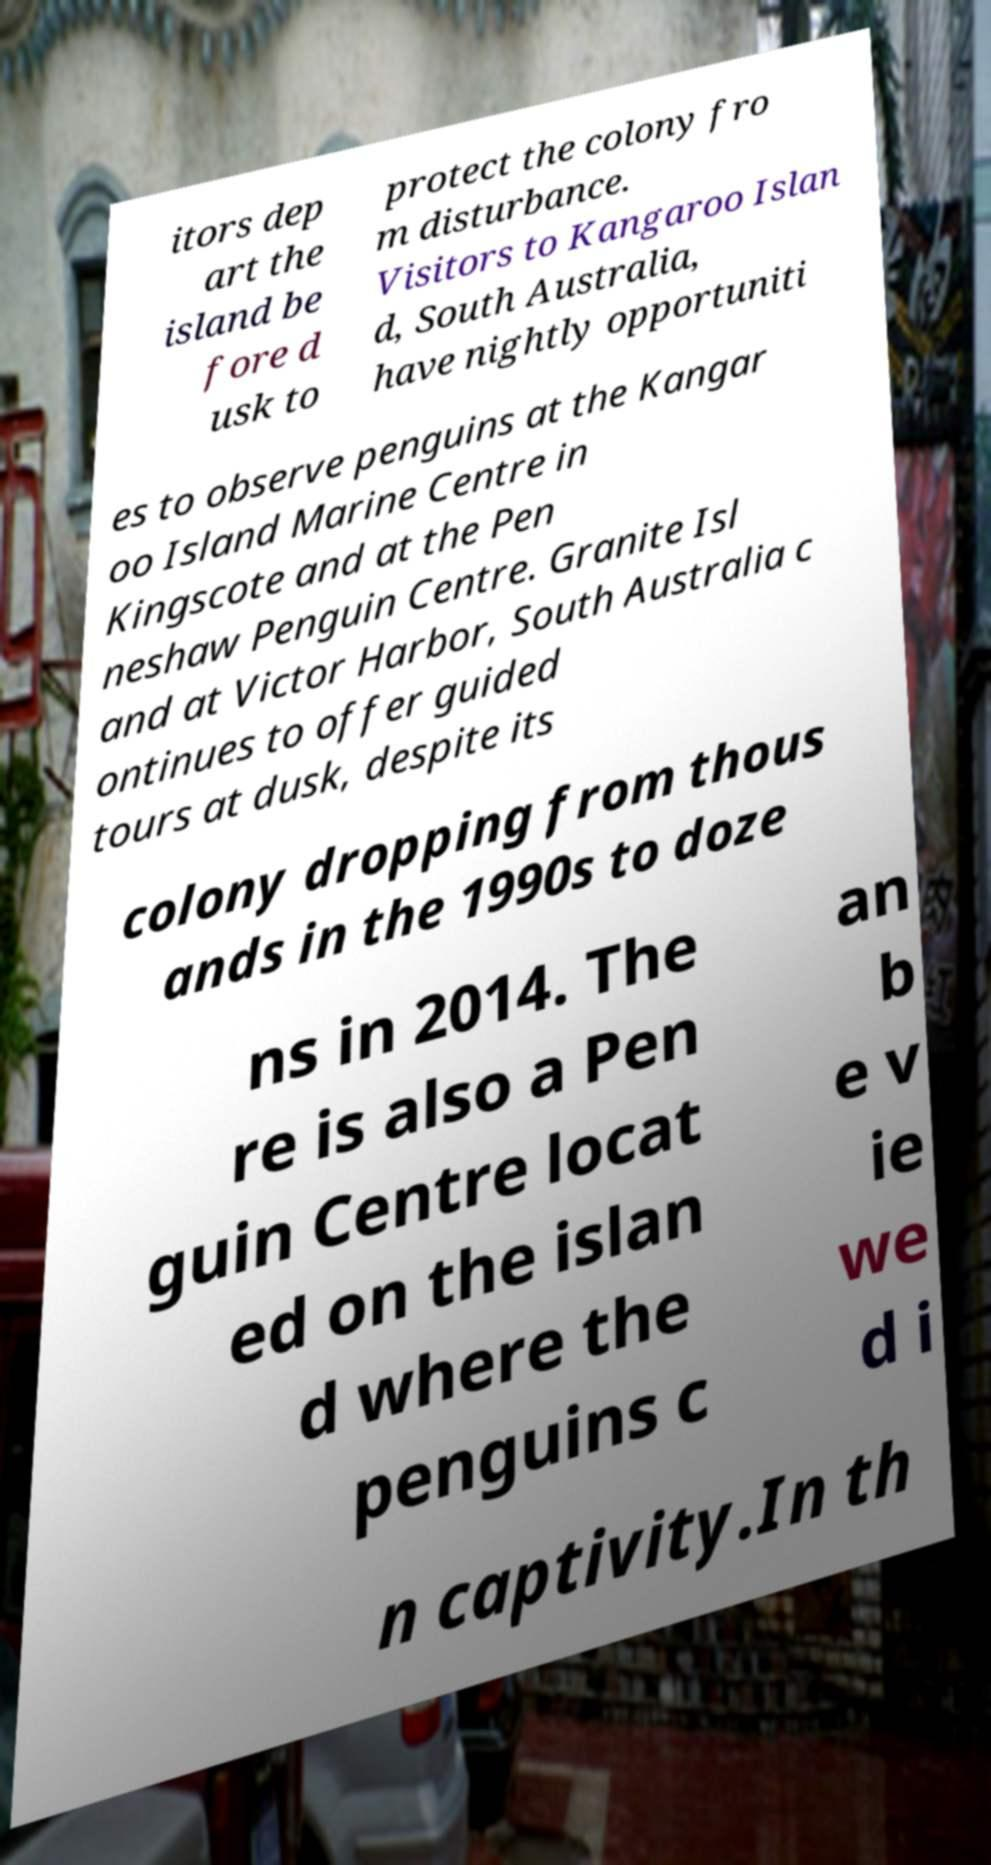For documentation purposes, I need the text within this image transcribed. Could you provide that? itors dep art the island be fore d usk to protect the colony fro m disturbance. Visitors to Kangaroo Islan d, South Australia, have nightly opportuniti es to observe penguins at the Kangar oo Island Marine Centre in Kingscote and at the Pen neshaw Penguin Centre. Granite Isl and at Victor Harbor, South Australia c ontinues to offer guided tours at dusk, despite its colony dropping from thous ands in the 1990s to doze ns in 2014. The re is also a Pen guin Centre locat ed on the islan d where the penguins c an b e v ie we d i n captivity.In th 